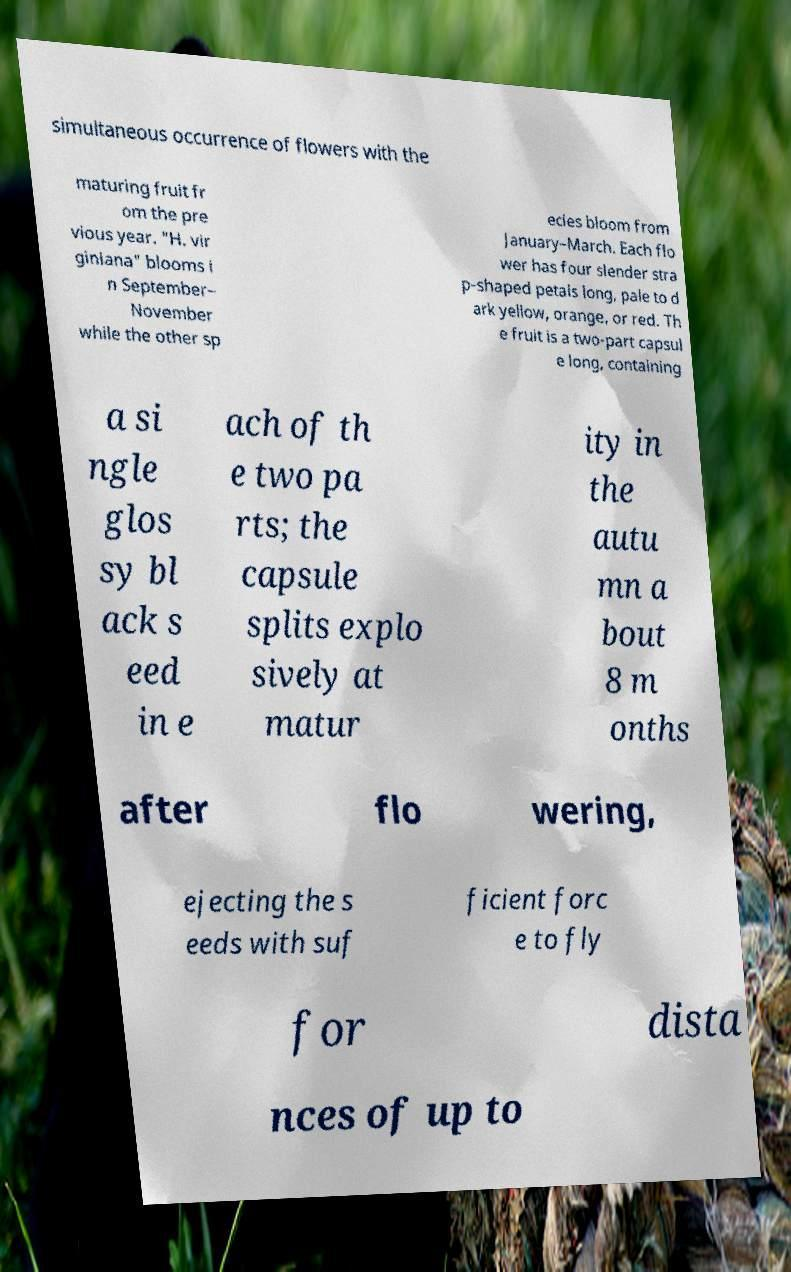Can you read and provide the text displayed in the image?This photo seems to have some interesting text. Can you extract and type it out for me? simultaneous occurrence of flowers with the maturing fruit fr om the pre vious year. "H. vir giniana" blooms i n September– November while the other sp ecies bloom from January–March. Each flo wer has four slender stra p-shaped petals long, pale to d ark yellow, orange, or red. Th e fruit is a two-part capsul e long, containing a si ngle glos sy bl ack s eed in e ach of th e two pa rts; the capsule splits explo sively at matur ity in the autu mn a bout 8 m onths after flo wering, ejecting the s eeds with suf ficient forc e to fly for dista nces of up to 